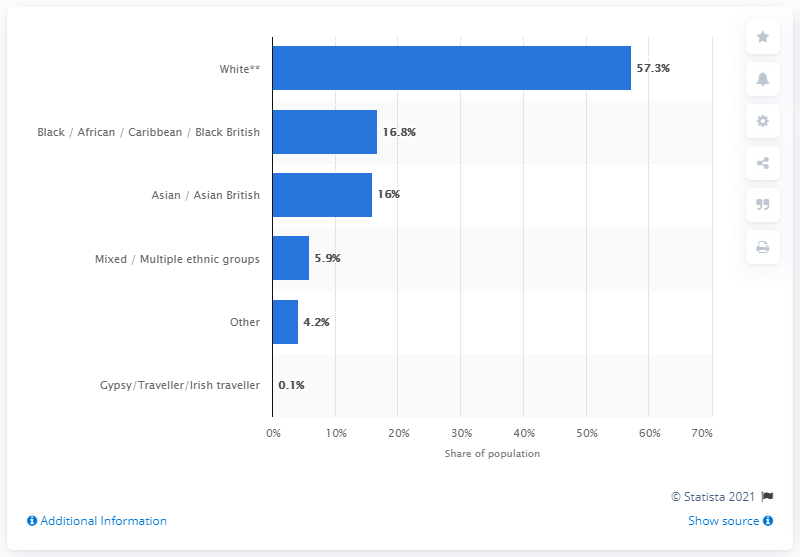Point out several critical features in this image. In Inner London, approximately 57.3% of the population identifies as white. In 2011, approximately 57.3% of the population in Inner London (UK) identified as White. In 2011, approximately 32.8% of the population in Inner London (UK) identified as Asian or Black/African. 